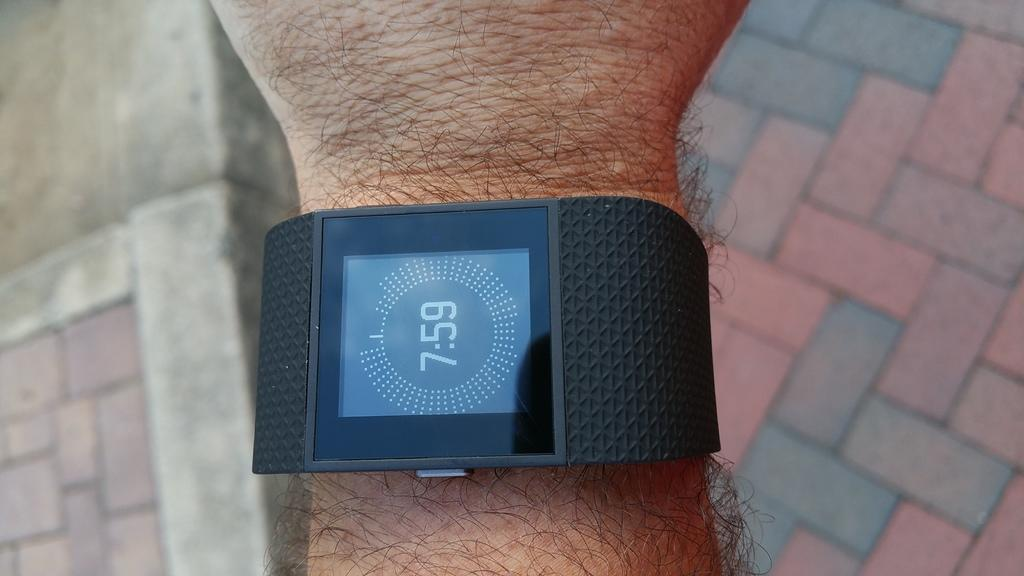<image>
Present a compact description of the photo's key features. a clock that has the time of 7:59 on it 